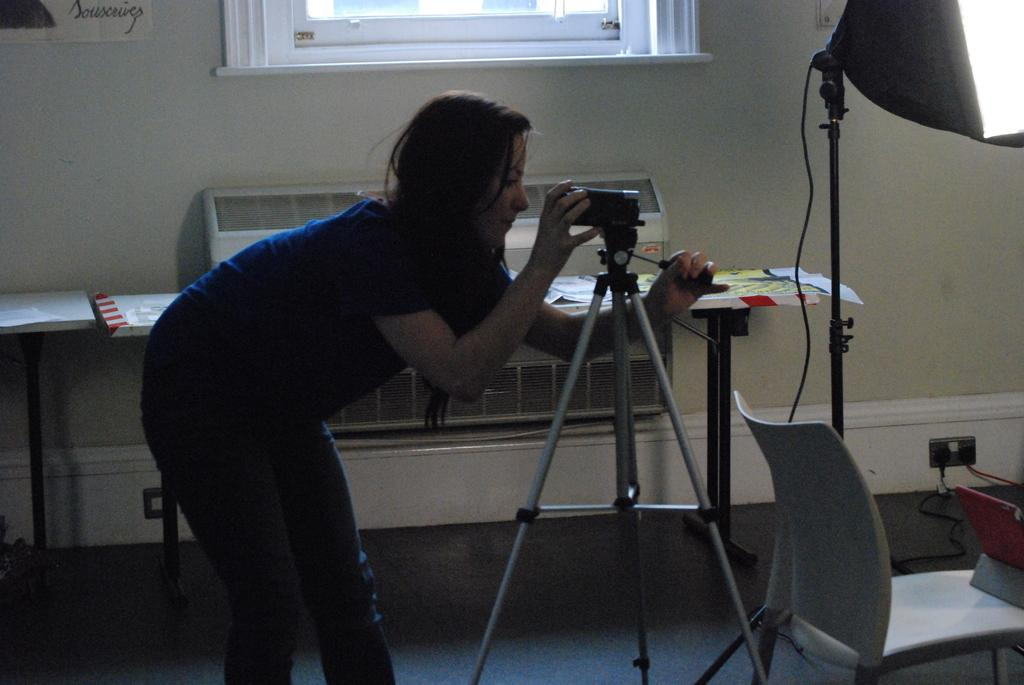Who is present in the image? There is a woman in the image. What is the woman doing in the image? The woman is standing and checking a video camera stand. What is in front of the woman? There is a chair in front of the woman. What is beside the woman? There are tables beside the woman. What type of wood is the zoo using to build the enclosures in the image? There is no zoo or wood present in the image; it features a woman checking a video camera stand. Is the writer in the image working on a new novel? There is no writer or novel mentioned in the image; it features a woman checking a video camera stand. 